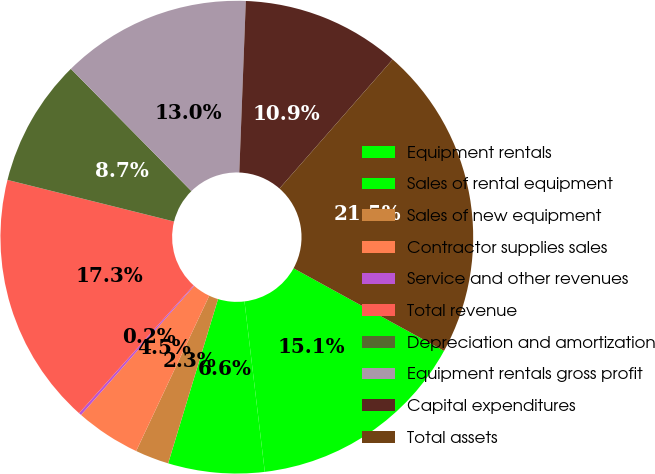<chart> <loc_0><loc_0><loc_500><loc_500><pie_chart><fcel>Equipment rentals<fcel>Sales of rental equipment<fcel>Sales of new equipment<fcel>Contractor supplies sales<fcel>Service and other revenues<fcel>Total revenue<fcel>Depreciation and amortization<fcel>Equipment rentals gross profit<fcel>Capital expenditures<fcel>Total assets<nl><fcel>15.12%<fcel>6.58%<fcel>2.31%<fcel>4.45%<fcel>0.18%<fcel>17.26%<fcel>8.72%<fcel>12.99%<fcel>10.85%<fcel>21.53%<nl></chart> 